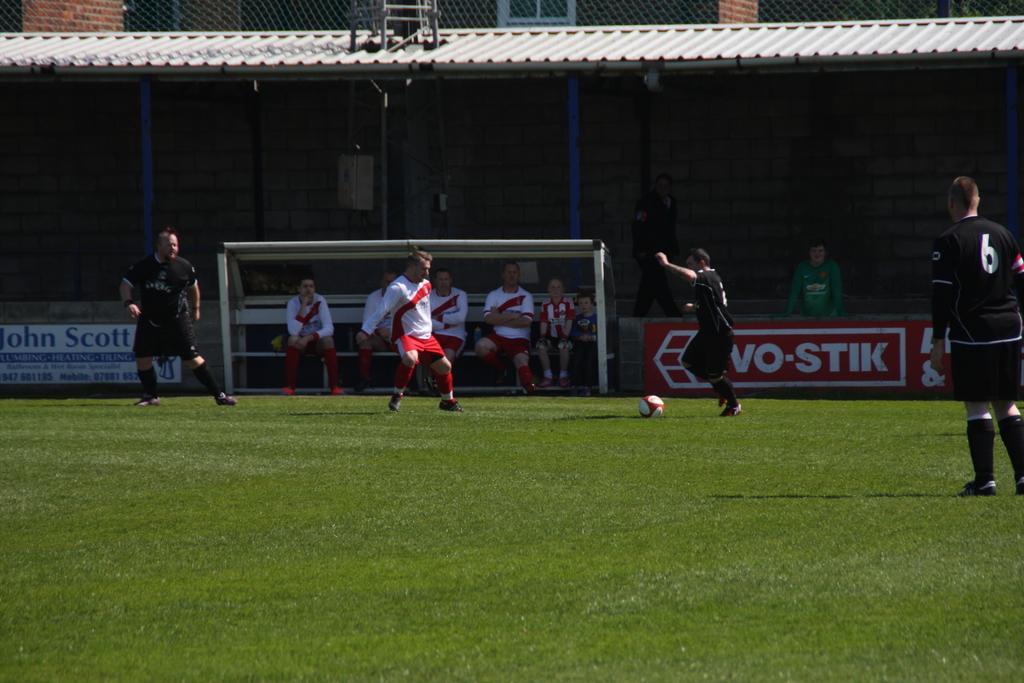How would you summarize this image in a sentence or two? In this image I can see there are so many people and ball on the ground, beside that there group of people sitting on the bench, at the back there is shed and building. 